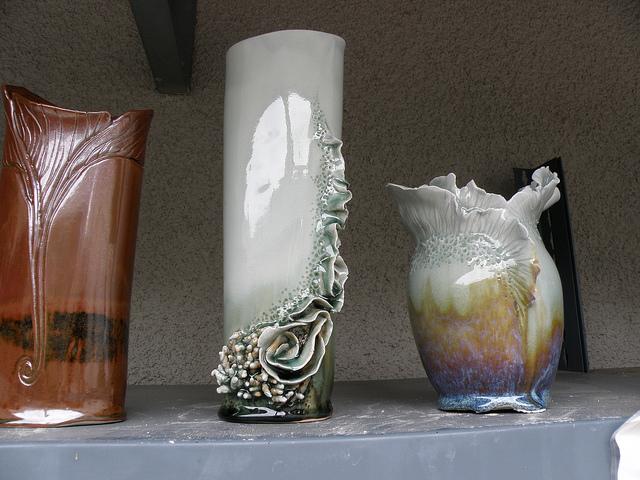Are these vessels watertight?
Concise answer only. No. Does these vases have texture?
Give a very brief answer. Yes. How many objects are in the picture?
Quick response, please. 3. 